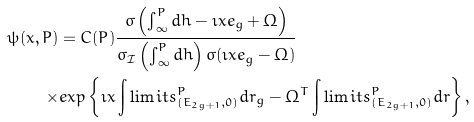Convert formula to latex. <formula><loc_0><loc_0><loc_500><loc_500>\psi ( x , P ) & = C ( P ) \frac { \sigma \left ( \int _ { \infty } ^ { P } d h - \imath x e _ { g } + \Omega \right ) } { \sigma _ { \mathcal { I } } \left ( \int _ { \infty } ^ { P } d h \right ) \sigma ( \imath x e _ { g } - \Omega ) } \\ \times & e x p \left \{ \imath x \int \lim i t s _ { ( E _ { 2 g + 1 } , 0 ) } ^ { P } d r _ { g } - \Omega ^ { T } \int \lim i t s _ { ( E _ { 2 g + 1 } , 0 ) } ^ { P } d r \right \} ,</formula> 